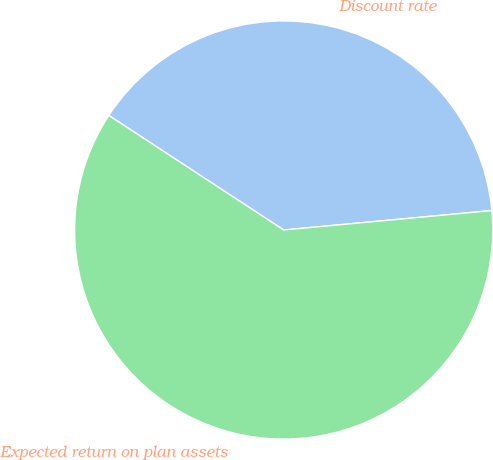Convert chart. <chart><loc_0><loc_0><loc_500><loc_500><pie_chart><fcel>Discount rate<fcel>Expected return on plan assets<nl><fcel>39.29%<fcel>60.71%<nl></chart> 